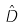Convert formula to latex. <formula><loc_0><loc_0><loc_500><loc_500>\hat { D }</formula> 